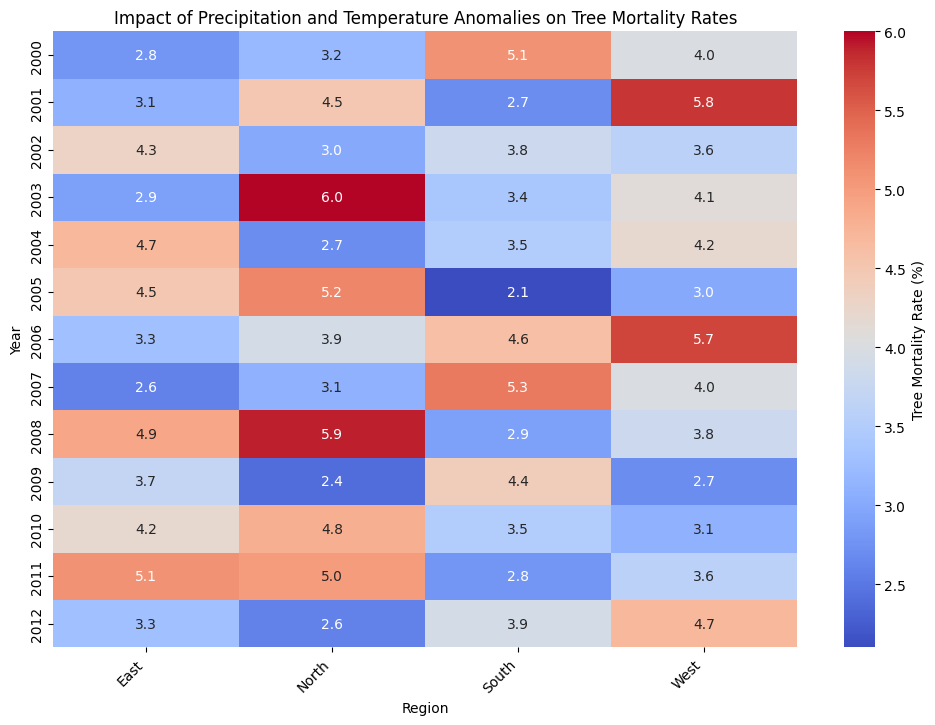What's the overall trend in tree mortality rates from 2000 to 2012? To determine the overall trend, observe the color gradient transition from cooler colors (indicating lower rates) to warmer colors (indicating higher rates) across the years. Note how the intensity of the colors changes over time across all regions.
Answer: Increasing Which region had the highest tree mortality rate in 2007? Look at the color intensity for the year 2007. The darkest shade (indicative of the highest value) should be identified. In 2007, the South region has the darkest shade indicating the highest rate.
Answer: South Which year had the lowest average tree mortality rate across all regions? Calculate the average tree mortality rate for each year across all regions by summing the mortality rates for that year and dividing by the number of regions. For direct visual estimation, identify the year with the lightest overall color intensity.
Answer: 2009 In which region and year did tree mortality rate peak throughout the period? Identify the cell with the darkest color intensity on the heatmap, and cross-reference the year and region labeled on the axes.
Answer: North 2003 Which year does the West region exhibit a distinct drop in tree mortality rate after a peak year? Observe the color transition in the West region across years. Identify the year with a darker shade followed by a significantly lighter shade the next year. The peak and drop are between 2006 (peak) and 2007 (drop).
Answer: 2007 How does the tree mortality rate in the South region in 2010 compare to the East region in the same year? Examine the heatmap for 2010 under both South and East regions. Compare the color intensities of the two cells. The intensity suggests South < East.
Answer: Lower Which year exhibited the widest range in tree mortality rates across different regions? Determine the year with the most noticeable difference in color intensity across regions, indicating the largest variance. You can detect this by looking at the starkest contrast within a single row.
Answer: 2003 In which region did the tree mortality rate increase steadily from 2008 to 2011? Examine each region's color progression from 2008 to 2011. Look for a sequential increase in color intensity. The North region's color deepens each year without fluctuations.
Answer: North 